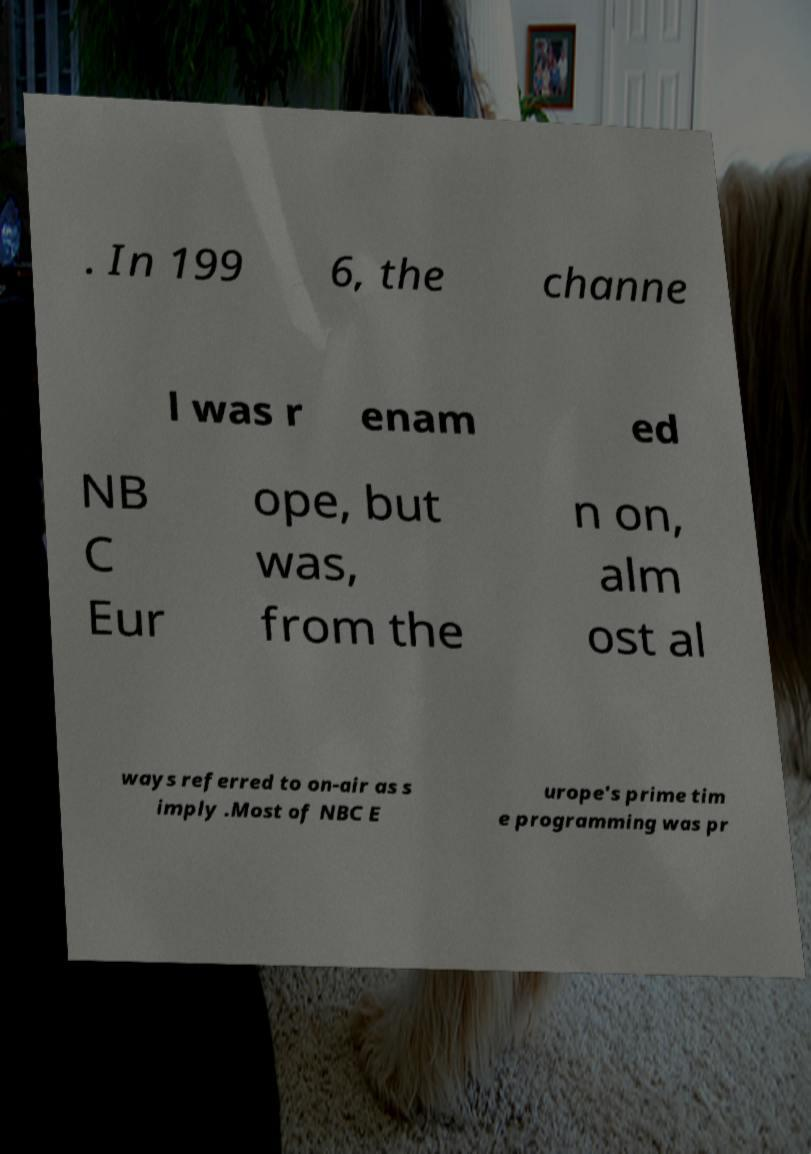Can you accurately transcribe the text from the provided image for me? . In 199 6, the channe l was r enam ed NB C Eur ope, but was, from the n on, alm ost al ways referred to on-air as s imply .Most of NBC E urope's prime tim e programming was pr 